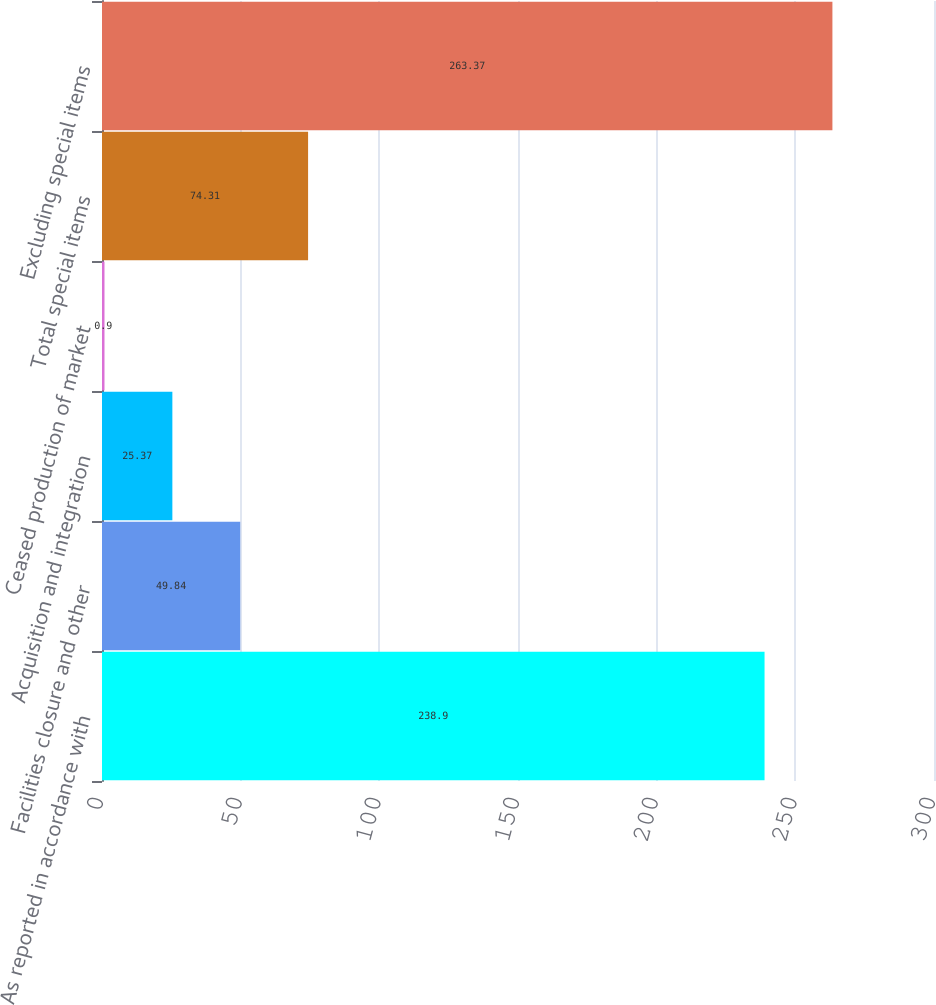Convert chart to OTSL. <chart><loc_0><loc_0><loc_500><loc_500><bar_chart><fcel>As reported in accordance with<fcel>Facilities closure and other<fcel>Acquisition and integration<fcel>Ceased production of market<fcel>Total special items<fcel>Excluding special items<nl><fcel>238.9<fcel>49.84<fcel>25.37<fcel>0.9<fcel>74.31<fcel>263.37<nl></chart> 